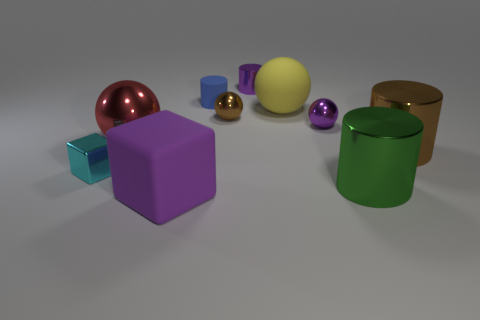What number of objects are big rubber things right of the blue rubber object or spheres that are right of the tiny blue rubber cylinder?
Keep it short and to the point. 3. What is the material of the yellow object?
Your response must be concise. Rubber. What number of other things are the same size as the yellow rubber sphere?
Ensure brevity in your answer.  4. How big is the purple object in front of the green shiny cylinder?
Provide a short and direct response. Large. What is the large sphere that is behind the brown thing that is left of the large shiny object in front of the cyan object made of?
Provide a short and direct response. Rubber. Do the purple matte thing and the tiny cyan metal thing have the same shape?
Your answer should be very brief. Yes. How many metal objects are either green cylinders or large balls?
Your answer should be very brief. 2. How many tiny blue objects are there?
Your response must be concise. 1. There is a matte object that is the same size as the rubber cube; what is its color?
Keep it short and to the point. Yellow. Do the brown shiny ball and the green shiny cylinder have the same size?
Offer a terse response. No. 